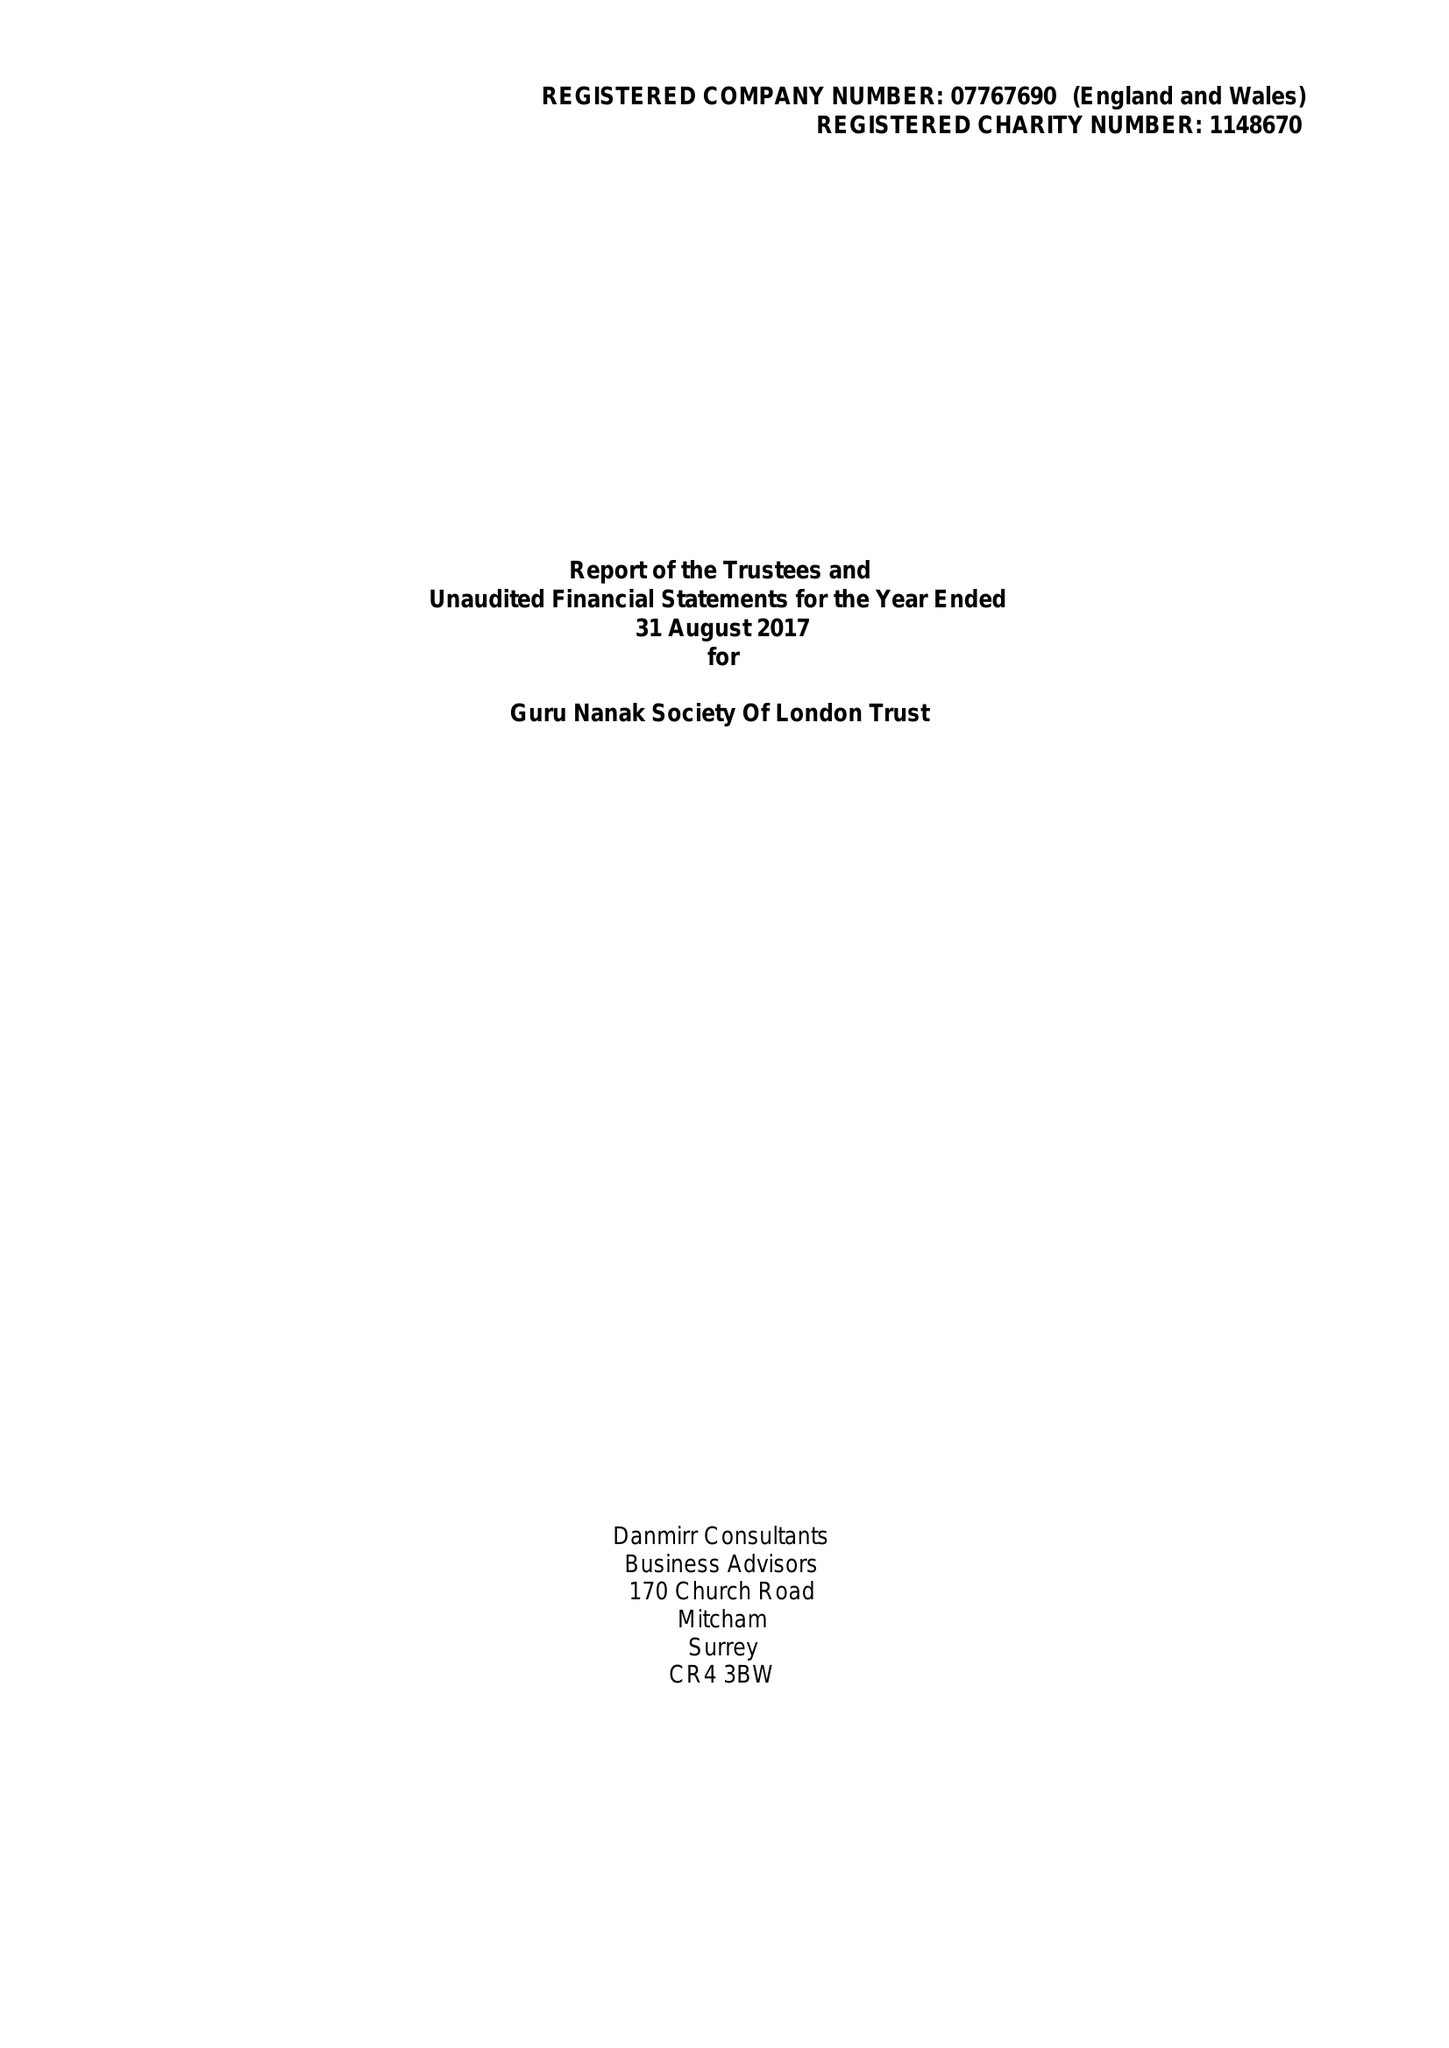What is the value for the spending_annually_in_british_pounds?
Answer the question using a single word or phrase. 13745.00 